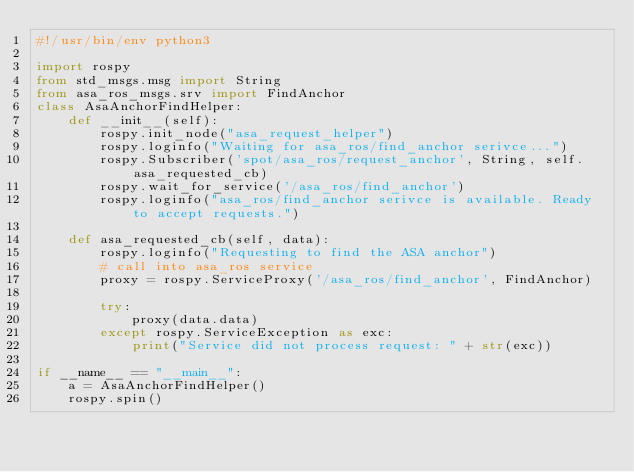<code> <loc_0><loc_0><loc_500><loc_500><_Python_>#!/usr/bin/env python3

import rospy
from std_msgs.msg import String 
from asa_ros_msgs.srv import FindAnchor
class AsaAnchorFindHelper:
    def __init__(self):
        rospy.init_node("asa_request_helper")
        rospy.loginfo("Waiting for asa_ros/find_anchor serivce...")
        rospy.Subscriber('spot/asa_ros/request_anchor', String, self.asa_requested_cb)
        rospy.wait_for_service('/asa_ros/find_anchor')
        rospy.loginfo("asa_ros/find_anchor serivce is available. Ready to accept requests.")
        
    def asa_requested_cb(self, data):
        rospy.loginfo("Requesting to find the ASA anchor")
        # call into asa_ros service
        proxy = rospy.ServiceProxy('/asa_ros/find_anchor', FindAnchor)
        
        try:
            proxy(data.data)
        except rospy.ServiceException as exc:
            print("Service did not process request: " + str(exc))

if __name__ == "__main__":
    a = AsaAnchorFindHelper()
    rospy.spin()
</code> 